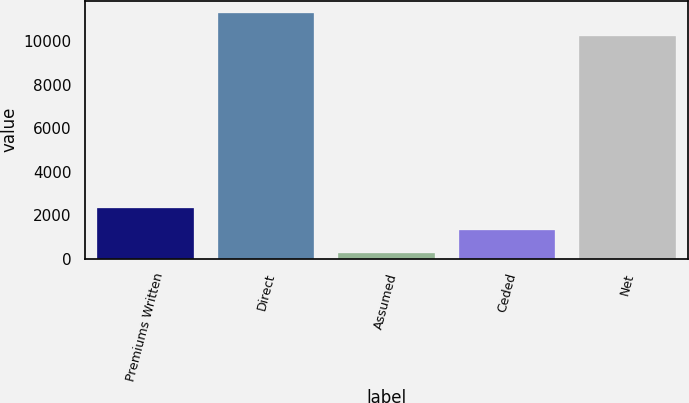Convert chart to OTSL. <chart><loc_0><loc_0><loc_500><loc_500><bar_chart><fcel>Premiums Written<fcel>Direct<fcel>Assumed<fcel>Ceded<fcel>Net<nl><fcel>2334.2<fcel>11273.6<fcel>275<fcel>1304.6<fcel>10244<nl></chart> 